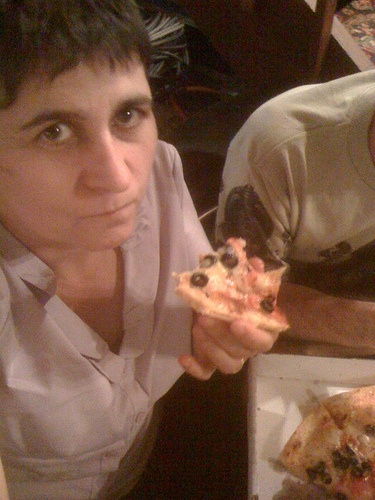Describe the objects in this image and their specific colors. I can see people in black, brown, maroon, and gray tones, people in black, brown, gray, maroon, and tan tones, dining table in black, tan, gray, and brown tones, dining table in black, maroon, and brown tones, and pizza in black, brown, gray, and maroon tones in this image. 